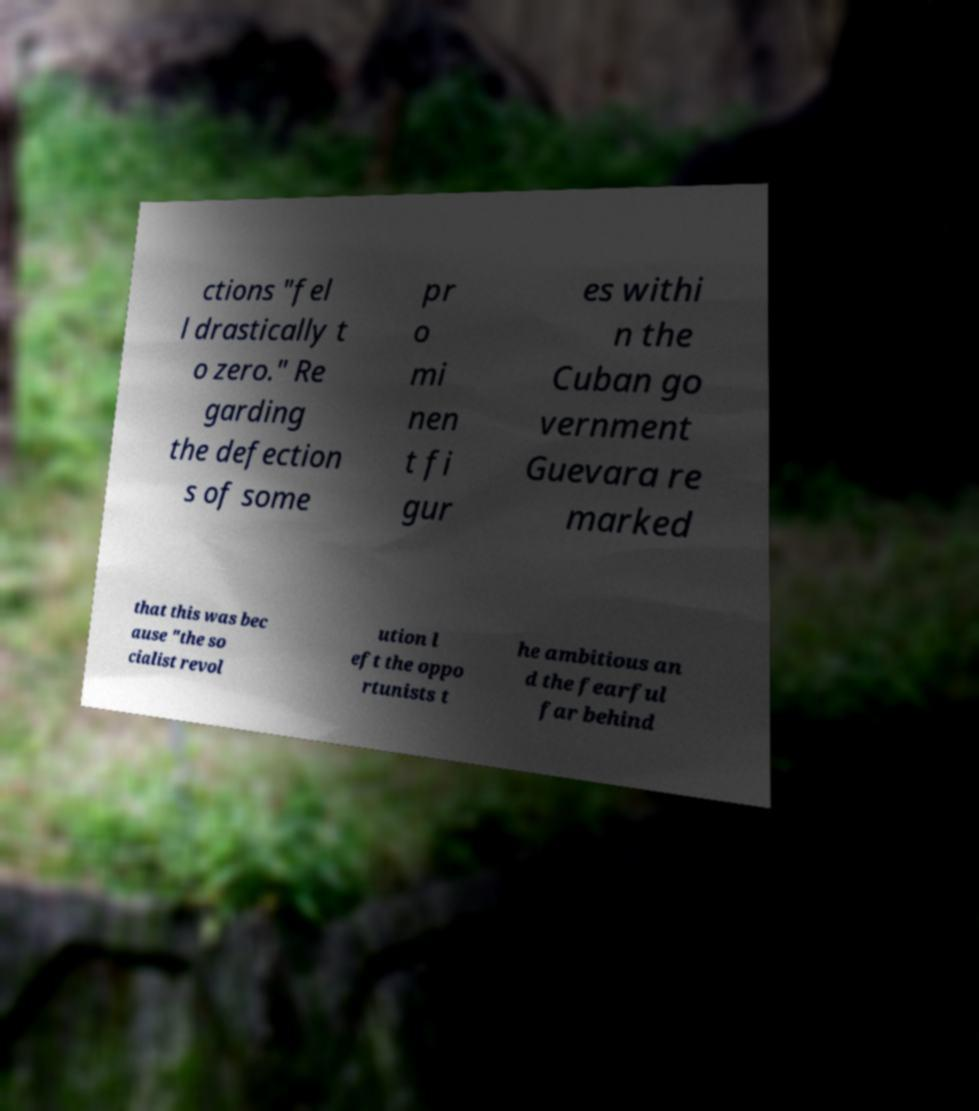What messages or text are displayed in this image? I need them in a readable, typed format. ctions "fel l drastically t o zero." Re garding the defection s of some pr o mi nen t fi gur es withi n the Cuban go vernment Guevara re marked that this was bec ause "the so cialist revol ution l eft the oppo rtunists t he ambitious an d the fearful far behind 